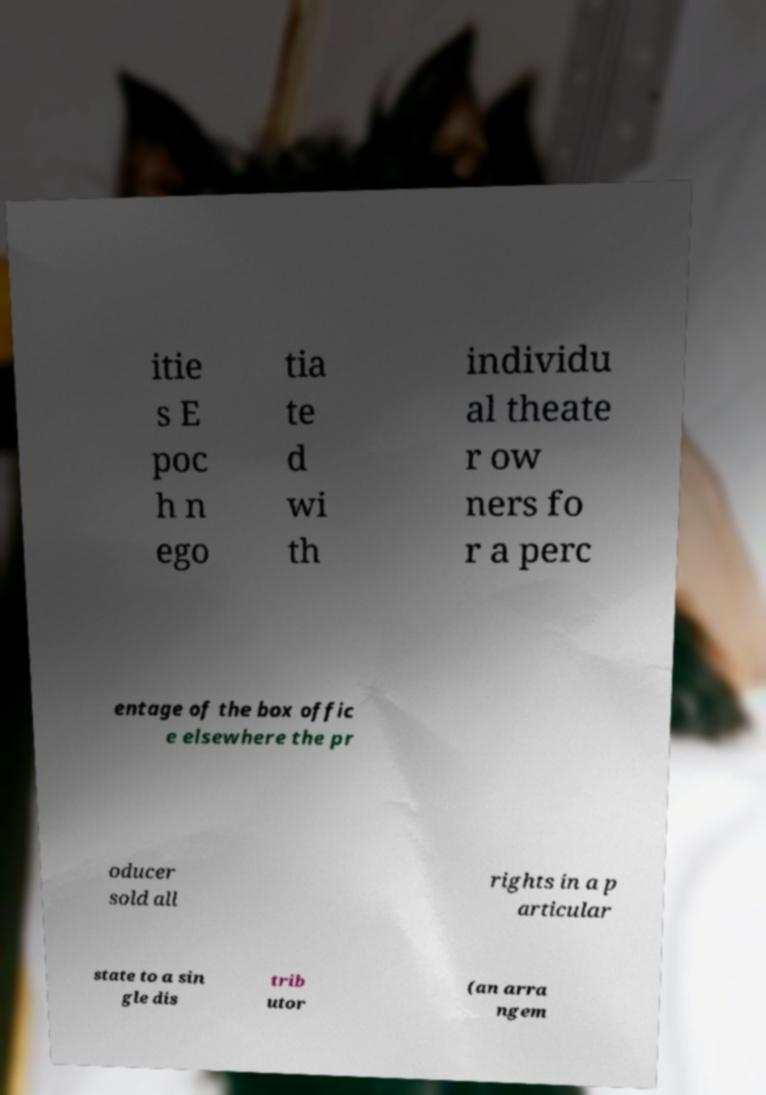Can you accurately transcribe the text from the provided image for me? itie s E poc h n ego tia te d wi th individu al theate r ow ners fo r a perc entage of the box offic e elsewhere the pr oducer sold all rights in a p articular state to a sin gle dis trib utor (an arra ngem 